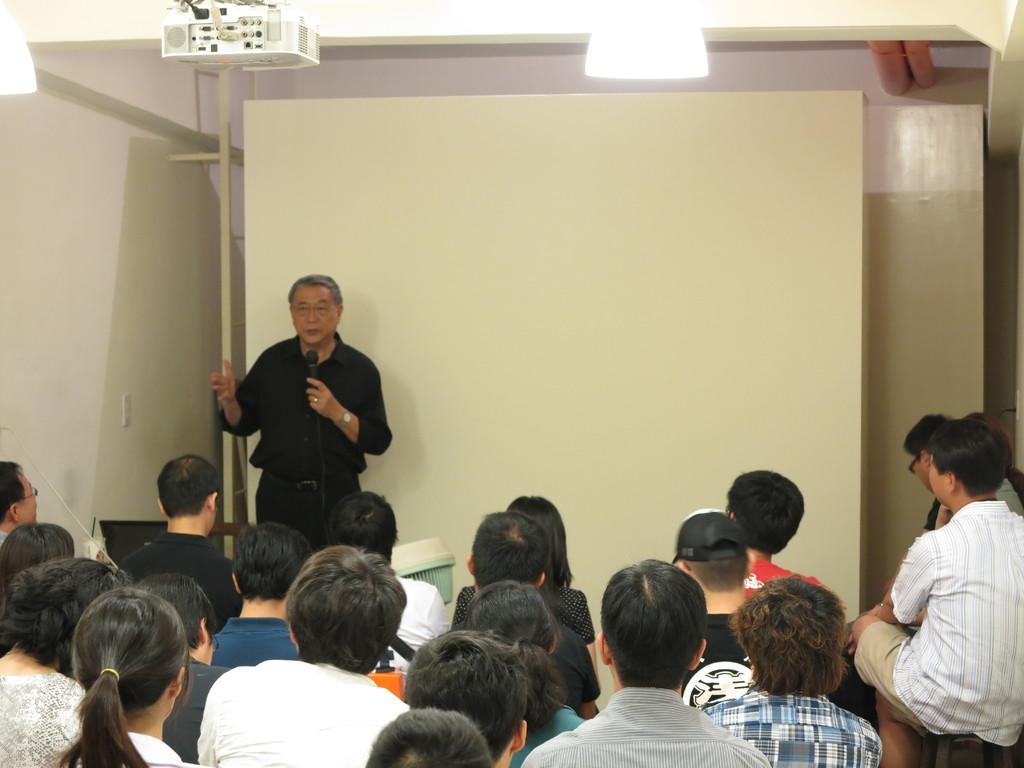Can you describe this image briefly? In this image we can see some people sitting in a room and there is a person standing and holding a mic and talking. in the background, we can see a board and there is a projector attached to the ceiling. 